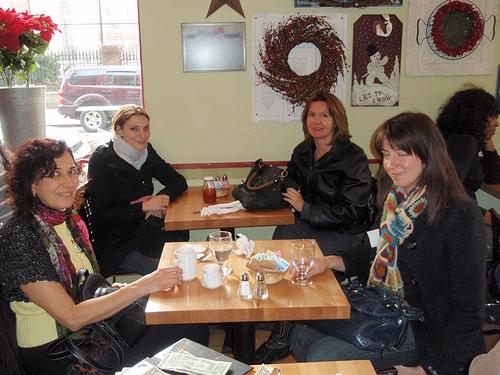How many women are wearing scarves?
Answer briefly. 3. Is the table made of marble?
Short answer required. No. How many people are at each table?
Answer briefly. 2. Is she holding a knife?
Write a very short answer. No. 